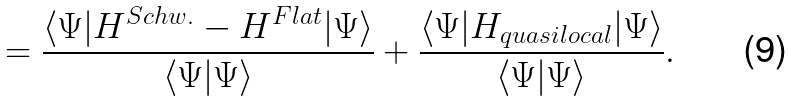<formula> <loc_0><loc_0><loc_500><loc_500>= \frac { \langle \Psi | H ^ { S c h w . } - H ^ { F l a t } | \Psi \rangle } { \langle \Psi | \Psi \rangle } + \frac { \langle \Psi | H _ { q u a s i l o c a l } | \Psi \rangle } { \langle \Psi | \Psi \rangle } .</formula> 